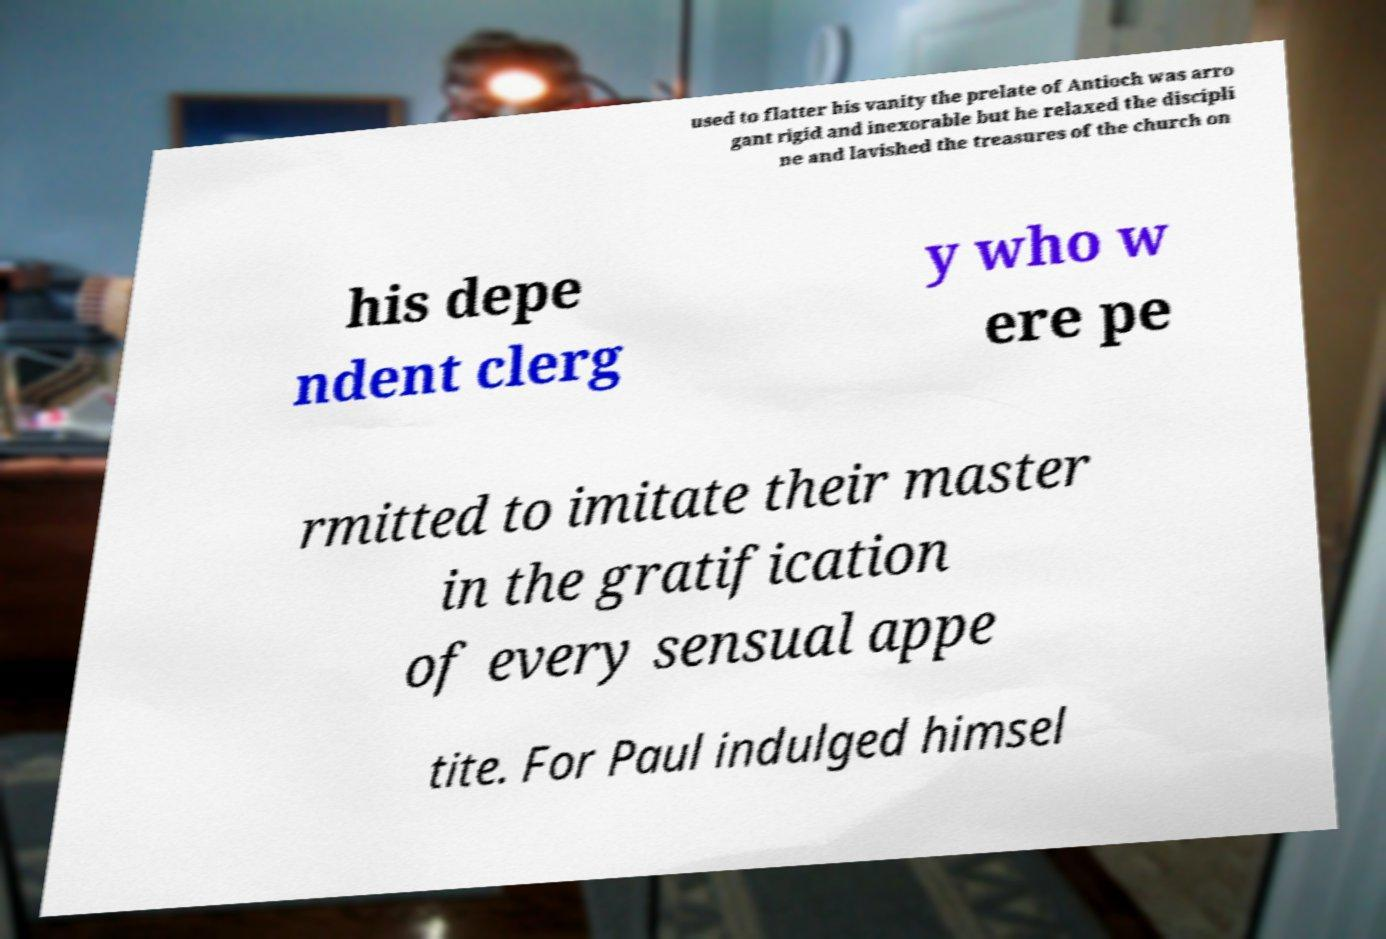For documentation purposes, I need the text within this image transcribed. Could you provide that? used to flatter his vanity the prelate of Antioch was arro gant rigid and inexorable but he relaxed the discipli ne and lavished the treasures of the church on his depe ndent clerg y who w ere pe rmitted to imitate their master in the gratification of every sensual appe tite. For Paul indulged himsel 